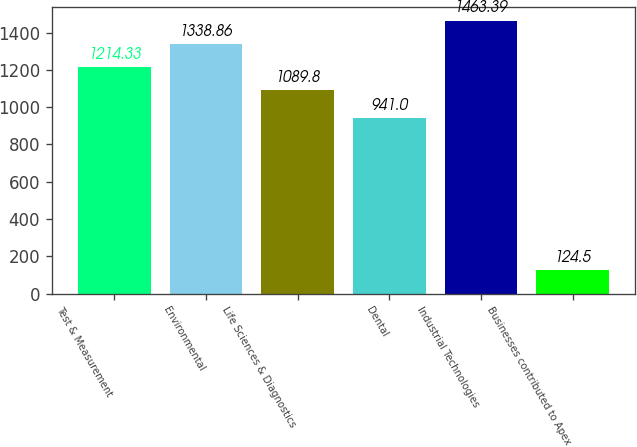<chart> <loc_0><loc_0><loc_500><loc_500><bar_chart><fcel>Test & Measurement<fcel>Environmental<fcel>Life Sciences & Diagnostics<fcel>Dental<fcel>Industrial Technologies<fcel>Businesses contributed to Apex<nl><fcel>1214.33<fcel>1338.86<fcel>1089.8<fcel>941<fcel>1463.39<fcel>124.5<nl></chart> 